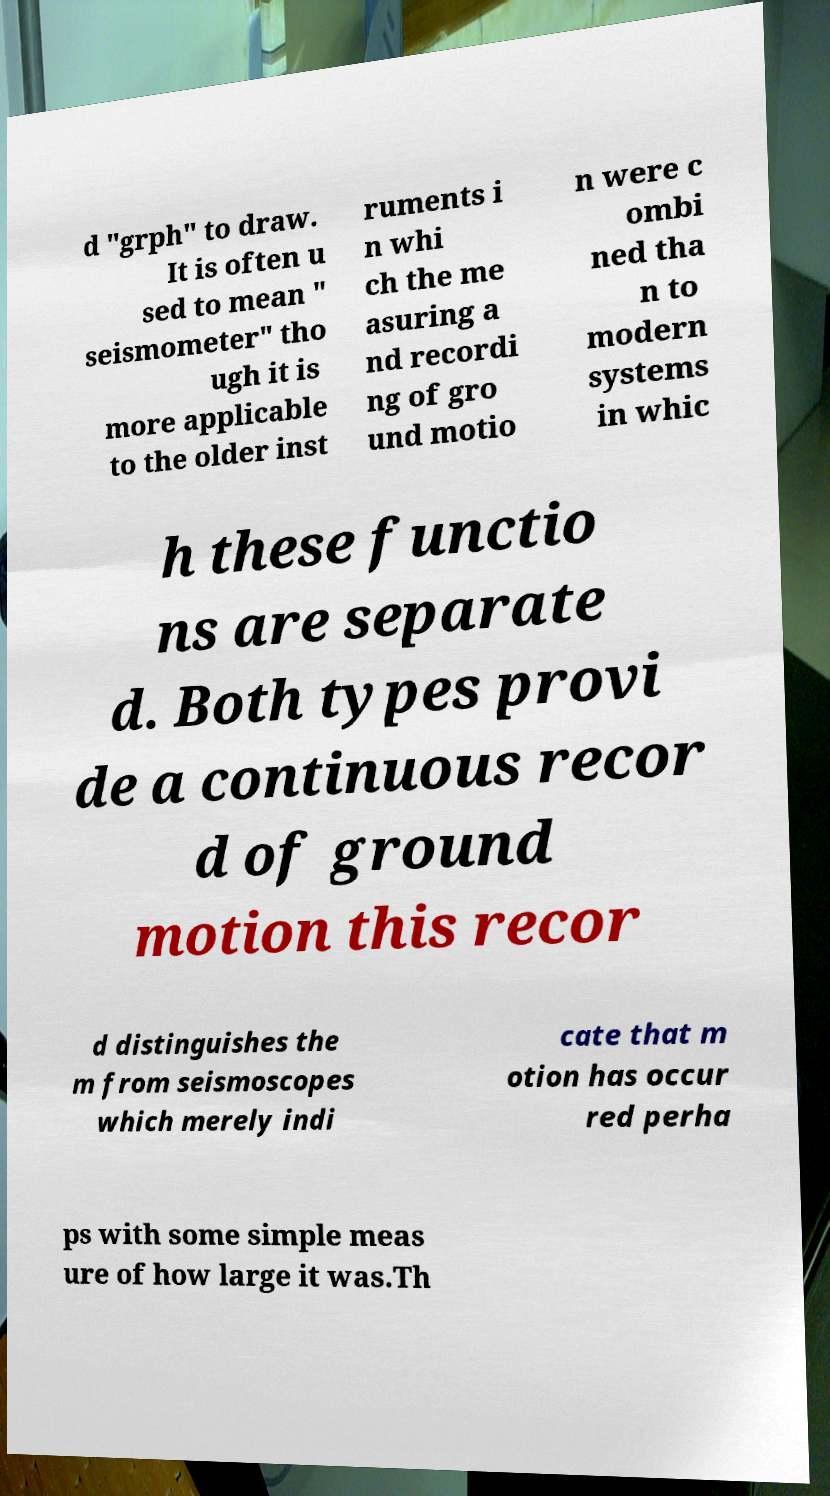What messages or text are displayed in this image? I need them in a readable, typed format. d "grph" to draw. It is often u sed to mean " seismometer" tho ugh it is more applicable to the older inst ruments i n whi ch the me asuring a nd recordi ng of gro und motio n were c ombi ned tha n to modern systems in whic h these functio ns are separate d. Both types provi de a continuous recor d of ground motion this recor d distinguishes the m from seismoscopes which merely indi cate that m otion has occur red perha ps with some simple meas ure of how large it was.Th 